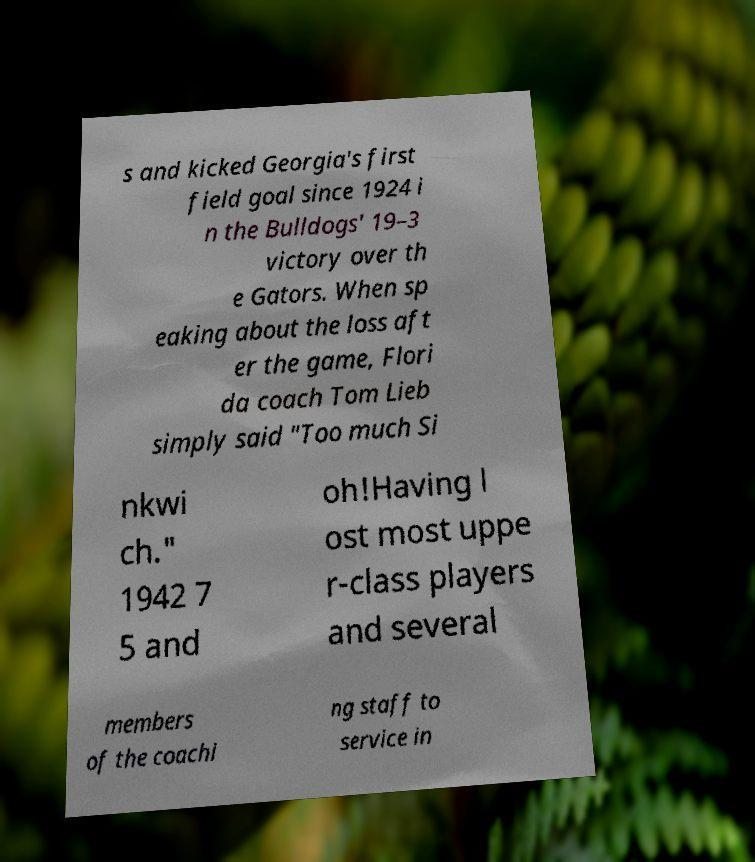Could you extract and type out the text from this image? s and kicked Georgia's first field goal since 1924 i n the Bulldogs' 19–3 victory over th e Gators. When sp eaking about the loss aft er the game, Flori da coach Tom Lieb simply said "Too much Si nkwi ch." 1942 7 5 and oh!Having l ost most uppe r-class players and several members of the coachi ng staff to service in 